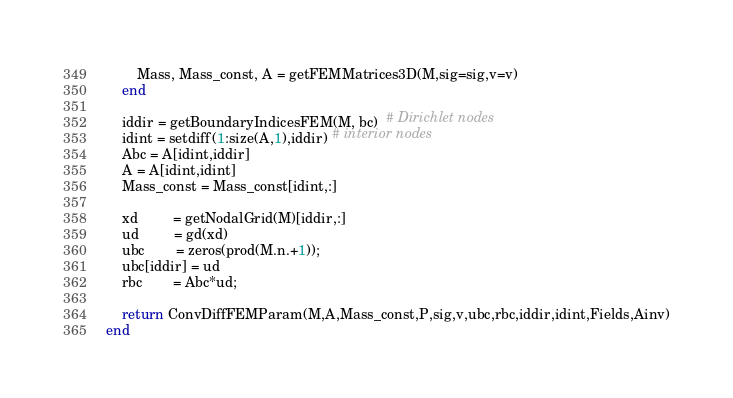Convert code to text. <code><loc_0><loc_0><loc_500><loc_500><_Julia_>		Mass, Mass_const, A = getFEMMatrices3D(M,sig=sig,v=v)
	end
	
	iddir = getBoundaryIndicesFEM(M, bc)  # Dirichlet nodes
	idint = setdiff(1:size(A,1),iddir) # interior nodes
	Abc = A[idint,iddir]
	A = A[idint,idint]
	Mass_const = Mass_const[idint,:]
	
	xd         = getNodalGrid(M)[iddir,:]	
	ud         = gd(xd)
	ubc        = zeros(prod(M.n.+1));
	ubc[iddir] = ud
	rbc        = Abc*ud;
	
	return ConvDiffFEMParam(M,A,Mass_const,P,sig,v,ubc,rbc,iddir,idint,Fields,Ainv)
end
</code> 